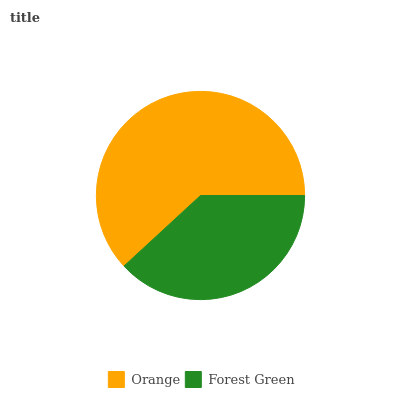Is Forest Green the minimum?
Answer yes or no. Yes. Is Orange the maximum?
Answer yes or no. Yes. Is Forest Green the maximum?
Answer yes or no. No. Is Orange greater than Forest Green?
Answer yes or no. Yes. Is Forest Green less than Orange?
Answer yes or no. Yes. Is Forest Green greater than Orange?
Answer yes or no. No. Is Orange less than Forest Green?
Answer yes or no. No. Is Orange the high median?
Answer yes or no. Yes. Is Forest Green the low median?
Answer yes or no. Yes. Is Forest Green the high median?
Answer yes or no. No. Is Orange the low median?
Answer yes or no. No. 